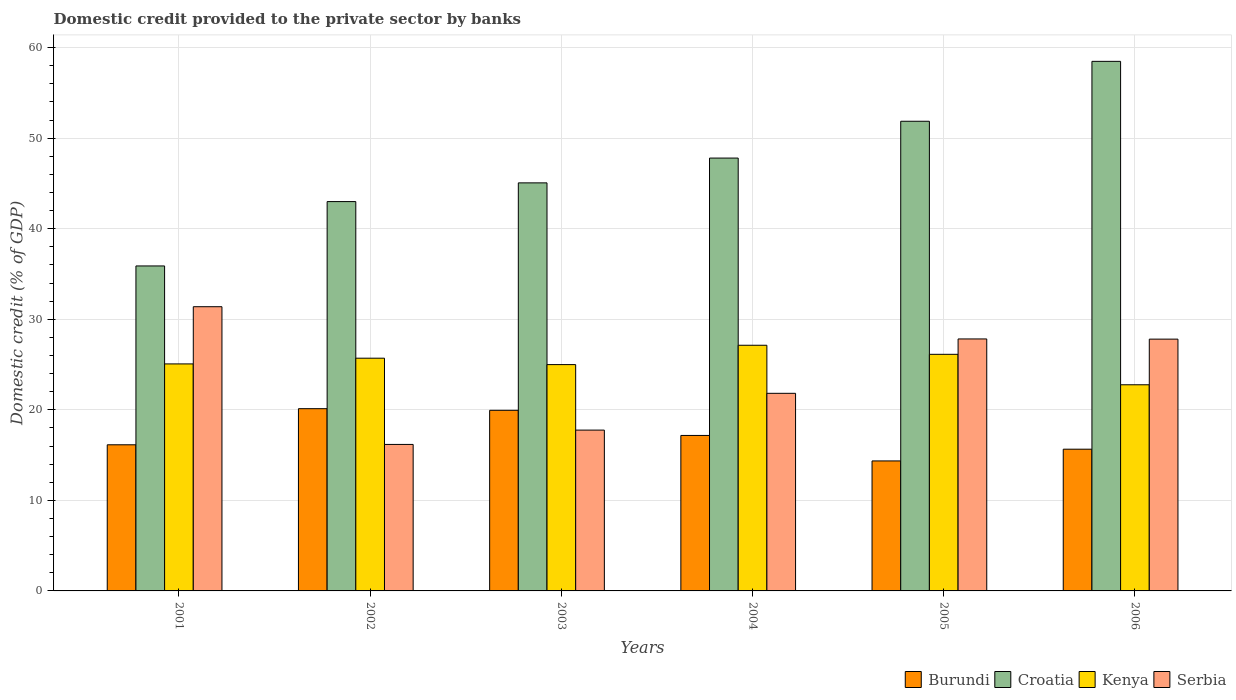How many groups of bars are there?
Make the answer very short. 6. How many bars are there on the 5th tick from the right?
Offer a terse response. 4. What is the label of the 3rd group of bars from the left?
Your response must be concise. 2003. In how many cases, is the number of bars for a given year not equal to the number of legend labels?
Provide a succinct answer. 0. What is the domestic credit provided to the private sector by banks in Serbia in 2003?
Your response must be concise. 17.76. Across all years, what is the maximum domestic credit provided to the private sector by banks in Croatia?
Give a very brief answer. 58.49. Across all years, what is the minimum domestic credit provided to the private sector by banks in Burundi?
Your answer should be compact. 14.36. In which year was the domestic credit provided to the private sector by banks in Burundi maximum?
Your answer should be very brief. 2002. What is the total domestic credit provided to the private sector by banks in Croatia in the graph?
Offer a very short reply. 282.12. What is the difference between the domestic credit provided to the private sector by banks in Serbia in 2001 and that in 2003?
Make the answer very short. 13.63. What is the difference between the domestic credit provided to the private sector by banks in Serbia in 2003 and the domestic credit provided to the private sector by banks in Burundi in 2001?
Provide a short and direct response. 1.62. What is the average domestic credit provided to the private sector by banks in Kenya per year?
Keep it short and to the point. 25.3. In the year 2006, what is the difference between the domestic credit provided to the private sector by banks in Croatia and domestic credit provided to the private sector by banks in Kenya?
Make the answer very short. 35.72. What is the ratio of the domestic credit provided to the private sector by banks in Kenya in 2002 to that in 2004?
Your response must be concise. 0.95. Is the domestic credit provided to the private sector by banks in Croatia in 2004 less than that in 2006?
Your response must be concise. Yes. Is the difference between the domestic credit provided to the private sector by banks in Croatia in 2003 and 2006 greater than the difference between the domestic credit provided to the private sector by banks in Kenya in 2003 and 2006?
Ensure brevity in your answer.  No. What is the difference between the highest and the second highest domestic credit provided to the private sector by banks in Serbia?
Offer a terse response. 3.56. What is the difference between the highest and the lowest domestic credit provided to the private sector by banks in Serbia?
Provide a succinct answer. 15.21. Is it the case that in every year, the sum of the domestic credit provided to the private sector by banks in Burundi and domestic credit provided to the private sector by banks in Kenya is greater than the sum of domestic credit provided to the private sector by banks in Croatia and domestic credit provided to the private sector by banks in Serbia?
Offer a very short reply. No. What does the 2nd bar from the left in 2002 represents?
Ensure brevity in your answer.  Croatia. What does the 2nd bar from the right in 2006 represents?
Your answer should be very brief. Kenya. Are all the bars in the graph horizontal?
Give a very brief answer. No. How many years are there in the graph?
Give a very brief answer. 6. Does the graph contain any zero values?
Make the answer very short. No. Where does the legend appear in the graph?
Provide a short and direct response. Bottom right. How many legend labels are there?
Your response must be concise. 4. How are the legend labels stacked?
Offer a very short reply. Horizontal. What is the title of the graph?
Provide a succinct answer. Domestic credit provided to the private sector by banks. Does "Malaysia" appear as one of the legend labels in the graph?
Your answer should be compact. No. What is the label or title of the X-axis?
Keep it short and to the point. Years. What is the label or title of the Y-axis?
Offer a terse response. Domestic credit (% of GDP). What is the Domestic credit (% of GDP) of Burundi in 2001?
Keep it short and to the point. 16.14. What is the Domestic credit (% of GDP) in Croatia in 2001?
Give a very brief answer. 35.89. What is the Domestic credit (% of GDP) in Kenya in 2001?
Your answer should be compact. 25.07. What is the Domestic credit (% of GDP) in Serbia in 2001?
Provide a succinct answer. 31.39. What is the Domestic credit (% of GDP) in Burundi in 2002?
Offer a very short reply. 20.13. What is the Domestic credit (% of GDP) of Croatia in 2002?
Your answer should be very brief. 43. What is the Domestic credit (% of GDP) of Kenya in 2002?
Make the answer very short. 25.7. What is the Domestic credit (% of GDP) in Serbia in 2002?
Give a very brief answer. 16.18. What is the Domestic credit (% of GDP) in Burundi in 2003?
Your answer should be very brief. 19.95. What is the Domestic credit (% of GDP) of Croatia in 2003?
Give a very brief answer. 45.07. What is the Domestic credit (% of GDP) of Kenya in 2003?
Your answer should be compact. 24.99. What is the Domestic credit (% of GDP) of Serbia in 2003?
Ensure brevity in your answer.  17.76. What is the Domestic credit (% of GDP) of Burundi in 2004?
Provide a short and direct response. 17.17. What is the Domestic credit (% of GDP) of Croatia in 2004?
Provide a short and direct response. 47.8. What is the Domestic credit (% of GDP) in Kenya in 2004?
Your answer should be compact. 27.13. What is the Domestic credit (% of GDP) of Serbia in 2004?
Offer a terse response. 21.82. What is the Domestic credit (% of GDP) of Burundi in 2005?
Offer a very short reply. 14.36. What is the Domestic credit (% of GDP) in Croatia in 2005?
Provide a short and direct response. 51.87. What is the Domestic credit (% of GDP) of Kenya in 2005?
Offer a terse response. 26.13. What is the Domestic credit (% of GDP) of Serbia in 2005?
Offer a very short reply. 27.83. What is the Domestic credit (% of GDP) of Burundi in 2006?
Your answer should be compact. 15.65. What is the Domestic credit (% of GDP) in Croatia in 2006?
Keep it short and to the point. 58.49. What is the Domestic credit (% of GDP) in Kenya in 2006?
Make the answer very short. 22.77. What is the Domestic credit (% of GDP) of Serbia in 2006?
Offer a very short reply. 27.81. Across all years, what is the maximum Domestic credit (% of GDP) in Burundi?
Provide a short and direct response. 20.13. Across all years, what is the maximum Domestic credit (% of GDP) of Croatia?
Your answer should be very brief. 58.49. Across all years, what is the maximum Domestic credit (% of GDP) in Kenya?
Your response must be concise. 27.13. Across all years, what is the maximum Domestic credit (% of GDP) of Serbia?
Offer a very short reply. 31.39. Across all years, what is the minimum Domestic credit (% of GDP) of Burundi?
Ensure brevity in your answer.  14.36. Across all years, what is the minimum Domestic credit (% of GDP) in Croatia?
Your answer should be compact. 35.89. Across all years, what is the minimum Domestic credit (% of GDP) of Kenya?
Provide a short and direct response. 22.77. Across all years, what is the minimum Domestic credit (% of GDP) of Serbia?
Provide a succinct answer. 16.18. What is the total Domestic credit (% of GDP) in Burundi in the graph?
Your response must be concise. 103.39. What is the total Domestic credit (% of GDP) in Croatia in the graph?
Offer a terse response. 282.12. What is the total Domestic credit (% of GDP) of Kenya in the graph?
Give a very brief answer. 151.8. What is the total Domestic credit (% of GDP) in Serbia in the graph?
Offer a terse response. 142.79. What is the difference between the Domestic credit (% of GDP) of Burundi in 2001 and that in 2002?
Your response must be concise. -3.99. What is the difference between the Domestic credit (% of GDP) in Croatia in 2001 and that in 2002?
Provide a succinct answer. -7.11. What is the difference between the Domestic credit (% of GDP) of Kenya in 2001 and that in 2002?
Offer a terse response. -0.63. What is the difference between the Domestic credit (% of GDP) of Serbia in 2001 and that in 2002?
Ensure brevity in your answer.  15.21. What is the difference between the Domestic credit (% of GDP) in Burundi in 2001 and that in 2003?
Make the answer very short. -3.81. What is the difference between the Domestic credit (% of GDP) of Croatia in 2001 and that in 2003?
Keep it short and to the point. -9.18. What is the difference between the Domestic credit (% of GDP) in Kenya in 2001 and that in 2003?
Give a very brief answer. 0.08. What is the difference between the Domestic credit (% of GDP) of Serbia in 2001 and that in 2003?
Make the answer very short. 13.63. What is the difference between the Domestic credit (% of GDP) in Burundi in 2001 and that in 2004?
Make the answer very short. -1.03. What is the difference between the Domestic credit (% of GDP) in Croatia in 2001 and that in 2004?
Give a very brief answer. -11.91. What is the difference between the Domestic credit (% of GDP) in Kenya in 2001 and that in 2004?
Offer a terse response. -2.06. What is the difference between the Domestic credit (% of GDP) in Serbia in 2001 and that in 2004?
Provide a short and direct response. 9.56. What is the difference between the Domestic credit (% of GDP) of Burundi in 2001 and that in 2005?
Make the answer very short. 1.78. What is the difference between the Domestic credit (% of GDP) in Croatia in 2001 and that in 2005?
Offer a very short reply. -15.98. What is the difference between the Domestic credit (% of GDP) of Kenya in 2001 and that in 2005?
Give a very brief answer. -1.06. What is the difference between the Domestic credit (% of GDP) of Serbia in 2001 and that in 2005?
Your answer should be very brief. 3.56. What is the difference between the Domestic credit (% of GDP) in Burundi in 2001 and that in 2006?
Make the answer very short. 0.49. What is the difference between the Domestic credit (% of GDP) of Croatia in 2001 and that in 2006?
Give a very brief answer. -22.6. What is the difference between the Domestic credit (% of GDP) in Kenya in 2001 and that in 2006?
Make the answer very short. 2.3. What is the difference between the Domestic credit (% of GDP) of Serbia in 2001 and that in 2006?
Your response must be concise. 3.58. What is the difference between the Domestic credit (% of GDP) in Burundi in 2002 and that in 2003?
Make the answer very short. 0.18. What is the difference between the Domestic credit (% of GDP) of Croatia in 2002 and that in 2003?
Provide a succinct answer. -2.07. What is the difference between the Domestic credit (% of GDP) of Kenya in 2002 and that in 2003?
Offer a very short reply. 0.71. What is the difference between the Domestic credit (% of GDP) of Serbia in 2002 and that in 2003?
Keep it short and to the point. -1.58. What is the difference between the Domestic credit (% of GDP) in Burundi in 2002 and that in 2004?
Provide a short and direct response. 2.96. What is the difference between the Domestic credit (% of GDP) in Croatia in 2002 and that in 2004?
Keep it short and to the point. -4.81. What is the difference between the Domestic credit (% of GDP) in Kenya in 2002 and that in 2004?
Your answer should be compact. -1.43. What is the difference between the Domestic credit (% of GDP) of Serbia in 2002 and that in 2004?
Keep it short and to the point. -5.64. What is the difference between the Domestic credit (% of GDP) in Burundi in 2002 and that in 2005?
Give a very brief answer. 5.77. What is the difference between the Domestic credit (% of GDP) of Croatia in 2002 and that in 2005?
Ensure brevity in your answer.  -8.87. What is the difference between the Domestic credit (% of GDP) of Kenya in 2002 and that in 2005?
Ensure brevity in your answer.  -0.43. What is the difference between the Domestic credit (% of GDP) in Serbia in 2002 and that in 2005?
Give a very brief answer. -11.65. What is the difference between the Domestic credit (% of GDP) of Burundi in 2002 and that in 2006?
Make the answer very short. 4.47. What is the difference between the Domestic credit (% of GDP) of Croatia in 2002 and that in 2006?
Offer a very short reply. -15.49. What is the difference between the Domestic credit (% of GDP) in Kenya in 2002 and that in 2006?
Provide a succinct answer. 2.93. What is the difference between the Domestic credit (% of GDP) in Serbia in 2002 and that in 2006?
Keep it short and to the point. -11.63. What is the difference between the Domestic credit (% of GDP) in Burundi in 2003 and that in 2004?
Give a very brief answer. 2.78. What is the difference between the Domestic credit (% of GDP) of Croatia in 2003 and that in 2004?
Your response must be concise. -2.74. What is the difference between the Domestic credit (% of GDP) in Kenya in 2003 and that in 2004?
Provide a succinct answer. -2.14. What is the difference between the Domestic credit (% of GDP) in Serbia in 2003 and that in 2004?
Offer a very short reply. -4.06. What is the difference between the Domestic credit (% of GDP) in Burundi in 2003 and that in 2005?
Provide a succinct answer. 5.59. What is the difference between the Domestic credit (% of GDP) in Croatia in 2003 and that in 2005?
Offer a terse response. -6.8. What is the difference between the Domestic credit (% of GDP) in Kenya in 2003 and that in 2005?
Provide a short and direct response. -1.14. What is the difference between the Domestic credit (% of GDP) of Serbia in 2003 and that in 2005?
Offer a very short reply. -10.07. What is the difference between the Domestic credit (% of GDP) in Burundi in 2003 and that in 2006?
Make the answer very short. 4.29. What is the difference between the Domestic credit (% of GDP) in Croatia in 2003 and that in 2006?
Provide a short and direct response. -13.42. What is the difference between the Domestic credit (% of GDP) in Kenya in 2003 and that in 2006?
Offer a terse response. 2.23. What is the difference between the Domestic credit (% of GDP) in Serbia in 2003 and that in 2006?
Your response must be concise. -10.05. What is the difference between the Domestic credit (% of GDP) in Burundi in 2004 and that in 2005?
Your answer should be compact. 2.81. What is the difference between the Domestic credit (% of GDP) in Croatia in 2004 and that in 2005?
Your answer should be very brief. -4.06. What is the difference between the Domestic credit (% of GDP) in Serbia in 2004 and that in 2005?
Make the answer very short. -6. What is the difference between the Domestic credit (% of GDP) of Burundi in 2004 and that in 2006?
Your answer should be very brief. 1.52. What is the difference between the Domestic credit (% of GDP) of Croatia in 2004 and that in 2006?
Make the answer very short. -10.68. What is the difference between the Domestic credit (% of GDP) in Kenya in 2004 and that in 2006?
Your answer should be compact. 4.36. What is the difference between the Domestic credit (% of GDP) in Serbia in 2004 and that in 2006?
Ensure brevity in your answer.  -5.98. What is the difference between the Domestic credit (% of GDP) in Burundi in 2005 and that in 2006?
Your answer should be very brief. -1.3. What is the difference between the Domestic credit (% of GDP) in Croatia in 2005 and that in 2006?
Your answer should be compact. -6.62. What is the difference between the Domestic credit (% of GDP) in Kenya in 2005 and that in 2006?
Make the answer very short. 3.36. What is the difference between the Domestic credit (% of GDP) in Serbia in 2005 and that in 2006?
Keep it short and to the point. 0.02. What is the difference between the Domestic credit (% of GDP) in Burundi in 2001 and the Domestic credit (% of GDP) in Croatia in 2002?
Keep it short and to the point. -26.86. What is the difference between the Domestic credit (% of GDP) of Burundi in 2001 and the Domestic credit (% of GDP) of Kenya in 2002?
Ensure brevity in your answer.  -9.56. What is the difference between the Domestic credit (% of GDP) in Burundi in 2001 and the Domestic credit (% of GDP) in Serbia in 2002?
Offer a very short reply. -0.04. What is the difference between the Domestic credit (% of GDP) of Croatia in 2001 and the Domestic credit (% of GDP) of Kenya in 2002?
Make the answer very short. 10.19. What is the difference between the Domestic credit (% of GDP) in Croatia in 2001 and the Domestic credit (% of GDP) in Serbia in 2002?
Provide a succinct answer. 19.71. What is the difference between the Domestic credit (% of GDP) in Kenya in 2001 and the Domestic credit (% of GDP) in Serbia in 2002?
Make the answer very short. 8.89. What is the difference between the Domestic credit (% of GDP) of Burundi in 2001 and the Domestic credit (% of GDP) of Croatia in 2003?
Make the answer very short. -28.93. What is the difference between the Domestic credit (% of GDP) of Burundi in 2001 and the Domestic credit (% of GDP) of Kenya in 2003?
Provide a succinct answer. -8.86. What is the difference between the Domestic credit (% of GDP) in Burundi in 2001 and the Domestic credit (% of GDP) in Serbia in 2003?
Ensure brevity in your answer.  -1.62. What is the difference between the Domestic credit (% of GDP) in Croatia in 2001 and the Domestic credit (% of GDP) in Kenya in 2003?
Keep it short and to the point. 10.9. What is the difference between the Domestic credit (% of GDP) in Croatia in 2001 and the Domestic credit (% of GDP) in Serbia in 2003?
Make the answer very short. 18.13. What is the difference between the Domestic credit (% of GDP) in Kenya in 2001 and the Domestic credit (% of GDP) in Serbia in 2003?
Make the answer very short. 7.31. What is the difference between the Domestic credit (% of GDP) in Burundi in 2001 and the Domestic credit (% of GDP) in Croatia in 2004?
Your answer should be very brief. -31.67. What is the difference between the Domestic credit (% of GDP) in Burundi in 2001 and the Domestic credit (% of GDP) in Kenya in 2004?
Make the answer very short. -10.99. What is the difference between the Domestic credit (% of GDP) in Burundi in 2001 and the Domestic credit (% of GDP) in Serbia in 2004?
Keep it short and to the point. -5.68. What is the difference between the Domestic credit (% of GDP) in Croatia in 2001 and the Domestic credit (% of GDP) in Kenya in 2004?
Give a very brief answer. 8.76. What is the difference between the Domestic credit (% of GDP) in Croatia in 2001 and the Domestic credit (% of GDP) in Serbia in 2004?
Make the answer very short. 14.07. What is the difference between the Domestic credit (% of GDP) in Kenya in 2001 and the Domestic credit (% of GDP) in Serbia in 2004?
Ensure brevity in your answer.  3.25. What is the difference between the Domestic credit (% of GDP) of Burundi in 2001 and the Domestic credit (% of GDP) of Croatia in 2005?
Offer a very short reply. -35.73. What is the difference between the Domestic credit (% of GDP) in Burundi in 2001 and the Domestic credit (% of GDP) in Kenya in 2005?
Your answer should be compact. -9.99. What is the difference between the Domestic credit (% of GDP) of Burundi in 2001 and the Domestic credit (% of GDP) of Serbia in 2005?
Offer a terse response. -11.69. What is the difference between the Domestic credit (% of GDP) in Croatia in 2001 and the Domestic credit (% of GDP) in Kenya in 2005?
Keep it short and to the point. 9.76. What is the difference between the Domestic credit (% of GDP) in Croatia in 2001 and the Domestic credit (% of GDP) in Serbia in 2005?
Your answer should be compact. 8.06. What is the difference between the Domestic credit (% of GDP) of Kenya in 2001 and the Domestic credit (% of GDP) of Serbia in 2005?
Your response must be concise. -2.76. What is the difference between the Domestic credit (% of GDP) in Burundi in 2001 and the Domestic credit (% of GDP) in Croatia in 2006?
Your response must be concise. -42.35. What is the difference between the Domestic credit (% of GDP) of Burundi in 2001 and the Domestic credit (% of GDP) of Kenya in 2006?
Your response must be concise. -6.63. What is the difference between the Domestic credit (% of GDP) of Burundi in 2001 and the Domestic credit (% of GDP) of Serbia in 2006?
Your response must be concise. -11.67. What is the difference between the Domestic credit (% of GDP) of Croatia in 2001 and the Domestic credit (% of GDP) of Kenya in 2006?
Make the answer very short. 13.12. What is the difference between the Domestic credit (% of GDP) in Croatia in 2001 and the Domestic credit (% of GDP) in Serbia in 2006?
Make the answer very short. 8.08. What is the difference between the Domestic credit (% of GDP) in Kenya in 2001 and the Domestic credit (% of GDP) in Serbia in 2006?
Offer a terse response. -2.74. What is the difference between the Domestic credit (% of GDP) in Burundi in 2002 and the Domestic credit (% of GDP) in Croatia in 2003?
Your answer should be very brief. -24.94. What is the difference between the Domestic credit (% of GDP) of Burundi in 2002 and the Domestic credit (% of GDP) of Kenya in 2003?
Your response must be concise. -4.87. What is the difference between the Domestic credit (% of GDP) in Burundi in 2002 and the Domestic credit (% of GDP) in Serbia in 2003?
Provide a succinct answer. 2.37. What is the difference between the Domestic credit (% of GDP) in Croatia in 2002 and the Domestic credit (% of GDP) in Kenya in 2003?
Your response must be concise. 18. What is the difference between the Domestic credit (% of GDP) of Croatia in 2002 and the Domestic credit (% of GDP) of Serbia in 2003?
Provide a short and direct response. 25.24. What is the difference between the Domestic credit (% of GDP) in Kenya in 2002 and the Domestic credit (% of GDP) in Serbia in 2003?
Your response must be concise. 7.94. What is the difference between the Domestic credit (% of GDP) in Burundi in 2002 and the Domestic credit (% of GDP) in Croatia in 2004?
Provide a succinct answer. -27.68. What is the difference between the Domestic credit (% of GDP) of Burundi in 2002 and the Domestic credit (% of GDP) of Kenya in 2004?
Give a very brief answer. -7.01. What is the difference between the Domestic credit (% of GDP) in Burundi in 2002 and the Domestic credit (% of GDP) in Serbia in 2004?
Ensure brevity in your answer.  -1.7. What is the difference between the Domestic credit (% of GDP) in Croatia in 2002 and the Domestic credit (% of GDP) in Kenya in 2004?
Keep it short and to the point. 15.87. What is the difference between the Domestic credit (% of GDP) of Croatia in 2002 and the Domestic credit (% of GDP) of Serbia in 2004?
Your answer should be compact. 21.18. What is the difference between the Domestic credit (% of GDP) in Kenya in 2002 and the Domestic credit (% of GDP) in Serbia in 2004?
Offer a terse response. 3.88. What is the difference between the Domestic credit (% of GDP) of Burundi in 2002 and the Domestic credit (% of GDP) of Croatia in 2005?
Provide a short and direct response. -31.74. What is the difference between the Domestic credit (% of GDP) of Burundi in 2002 and the Domestic credit (% of GDP) of Kenya in 2005?
Provide a succinct answer. -6.01. What is the difference between the Domestic credit (% of GDP) in Burundi in 2002 and the Domestic credit (% of GDP) in Serbia in 2005?
Offer a very short reply. -7.7. What is the difference between the Domestic credit (% of GDP) in Croatia in 2002 and the Domestic credit (% of GDP) in Kenya in 2005?
Offer a very short reply. 16.87. What is the difference between the Domestic credit (% of GDP) of Croatia in 2002 and the Domestic credit (% of GDP) of Serbia in 2005?
Keep it short and to the point. 15.17. What is the difference between the Domestic credit (% of GDP) of Kenya in 2002 and the Domestic credit (% of GDP) of Serbia in 2005?
Provide a succinct answer. -2.13. What is the difference between the Domestic credit (% of GDP) of Burundi in 2002 and the Domestic credit (% of GDP) of Croatia in 2006?
Offer a terse response. -38.36. What is the difference between the Domestic credit (% of GDP) of Burundi in 2002 and the Domestic credit (% of GDP) of Kenya in 2006?
Your response must be concise. -2.64. What is the difference between the Domestic credit (% of GDP) of Burundi in 2002 and the Domestic credit (% of GDP) of Serbia in 2006?
Keep it short and to the point. -7.68. What is the difference between the Domestic credit (% of GDP) of Croatia in 2002 and the Domestic credit (% of GDP) of Kenya in 2006?
Keep it short and to the point. 20.23. What is the difference between the Domestic credit (% of GDP) of Croatia in 2002 and the Domestic credit (% of GDP) of Serbia in 2006?
Your answer should be compact. 15.19. What is the difference between the Domestic credit (% of GDP) of Kenya in 2002 and the Domestic credit (% of GDP) of Serbia in 2006?
Give a very brief answer. -2.11. What is the difference between the Domestic credit (% of GDP) in Burundi in 2003 and the Domestic credit (% of GDP) in Croatia in 2004?
Keep it short and to the point. -27.86. What is the difference between the Domestic credit (% of GDP) of Burundi in 2003 and the Domestic credit (% of GDP) of Kenya in 2004?
Ensure brevity in your answer.  -7.18. What is the difference between the Domestic credit (% of GDP) of Burundi in 2003 and the Domestic credit (% of GDP) of Serbia in 2004?
Provide a succinct answer. -1.88. What is the difference between the Domestic credit (% of GDP) in Croatia in 2003 and the Domestic credit (% of GDP) in Kenya in 2004?
Your answer should be compact. 17.93. What is the difference between the Domestic credit (% of GDP) of Croatia in 2003 and the Domestic credit (% of GDP) of Serbia in 2004?
Provide a short and direct response. 23.24. What is the difference between the Domestic credit (% of GDP) of Kenya in 2003 and the Domestic credit (% of GDP) of Serbia in 2004?
Offer a terse response. 3.17. What is the difference between the Domestic credit (% of GDP) in Burundi in 2003 and the Domestic credit (% of GDP) in Croatia in 2005?
Your response must be concise. -31.92. What is the difference between the Domestic credit (% of GDP) in Burundi in 2003 and the Domestic credit (% of GDP) in Kenya in 2005?
Give a very brief answer. -6.18. What is the difference between the Domestic credit (% of GDP) in Burundi in 2003 and the Domestic credit (% of GDP) in Serbia in 2005?
Offer a terse response. -7.88. What is the difference between the Domestic credit (% of GDP) in Croatia in 2003 and the Domestic credit (% of GDP) in Kenya in 2005?
Your response must be concise. 18.93. What is the difference between the Domestic credit (% of GDP) in Croatia in 2003 and the Domestic credit (% of GDP) in Serbia in 2005?
Provide a succinct answer. 17.24. What is the difference between the Domestic credit (% of GDP) in Kenya in 2003 and the Domestic credit (% of GDP) in Serbia in 2005?
Give a very brief answer. -2.83. What is the difference between the Domestic credit (% of GDP) of Burundi in 2003 and the Domestic credit (% of GDP) of Croatia in 2006?
Provide a succinct answer. -38.54. What is the difference between the Domestic credit (% of GDP) of Burundi in 2003 and the Domestic credit (% of GDP) of Kenya in 2006?
Offer a terse response. -2.82. What is the difference between the Domestic credit (% of GDP) of Burundi in 2003 and the Domestic credit (% of GDP) of Serbia in 2006?
Make the answer very short. -7.86. What is the difference between the Domestic credit (% of GDP) of Croatia in 2003 and the Domestic credit (% of GDP) of Kenya in 2006?
Make the answer very short. 22.3. What is the difference between the Domestic credit (% of GDP) in Croatia in 2003 and the Domestic credit (% of GDP) in Serbia in 2006?
Give a very brief answer. 17.26. What is the difference between the Domestic credit (% of GDP) of Kenya in 2003 and the Domestic credit (% of GDP) of Serbia in 2006?
Make the answer very short. -2.81. What is the difference between the Domestic credit (% of GDP) in Burundi in 2004 and the Domestic credit (% of GDP) in Croatia in 2005?
Provide a succinct answer. -34.7. What is the difference between the Domestic credit (% of GDP) in Burundi in 2004 and the Domestic credit (% of GDP) in Kenya in 2005?
Keep it short and to the point. -8.96. What is the difference between the Domestic credit (% of GDP) in Burundi in 2004 and the Domestic credit (% of GDP) in Serbia in 2005?
Your answer should be compact. -10.66. What is the difference between the Domestic credit (% of GDP) of Croatia in 2004 and the Domestic credit (% of GDP) of Kenya in 2005?
Keep it short and to the point. 21.67. What is the difference between the Domestic credit (% of GDP) in Croatia in 2004 and the Domestic credit (% of GDP) in Serbia in 2005?
Your answer should be very brief. 19.98. What is the difference between the Domestic credit (% of GDP) in Kenya in 2004 and the Domestic credit (% of GDP) in Serbia in 2005?
Your response must be concise. -0.7. What is the difference between the Domestic credit (% of GDP) in Burundi in 2004 and the Domestic credit (% of GDP) in Croatia in 2006?
Keep it short and to the point. -41.32. What is the difference between the Domestic credit (% of GDP) in Burundi in 2004 and the Domestic credit (% of GDP) in Kenya in 2006?
Provide a short and direct response. -5.6. What is the difference between the Domestic credit (% of GDP) in Burundi in 2004 and the Domestic credit (% of GDP) in Serbia in 2006?
Your answer should be very brief. -10.64. What is the difference between the Domestic credit (% of GDP) in Croatia in 2004 and the Domestic credit (% of GDP) in Kenya in 2006?
Your response must be concise. 25.04. What is the difference between the Domestic credit (% of GDP) in Croatia in 2004 and the Domestic credit (% of GDP) in Serbia in 2006?
Keep it short and to the point. 20. What is the difference between the Domestic credit (% of GDP) of Kenya in 2004 and the Domestic credit (% of GDP) of Serbia in 2006?
Make the answer very short. -0.68. What is the difference between the Domestic credit (% of GDP) of Burundi in 2005 and the Domestic credit (% of GDP) of Croatia in 2006?
Provide a succinct answer. -44.13. What is the difference between the Domestic credit (% of GDP) in Burundi in 2005 and the Domestic credit (% of GDP) in Kenya in 2006?
Give a very brief answer. -8.41. What is the difference between the Domestic credit (% of GDP) of Burundi in 2005 and the Domestic credit (% of GDP) of Serbia in 2006?
Give a very brief answer. -13.45. What is the difference between the Domestic credit (% of GDP) of Croatia in 2005 and the Domestic credit (% of GDP) of Kenya in 2006?
Give a very brief answer. 29.1. What is the difference between the Domestic credit (% of GDP) of Croatia in 2005 and the Domestic credit (% of GDP) of Serbia in 2006?
Provide a short and direct response. 24.06. What is the difference between the Domestic credit (% of GDP) of Kenya in 2005 and the Domestic credit (% of GDP) of Serbia in 2006?
Your answer should be compact. -1.68. What is the average Domestic credit (% of GDP) in Burundi per year?
Offer a very short reply. 17.23. What is the average Domestic credit (% of GDP) of Croatia per year?
Give a very brief answer. 47.02. What is the average Domestic credit (% of GDP) in Kenya per year?
Offer a terse response. 25.3. What is the average Domestic credit (% of GDP) in Serbia per year?
Your response must be concise. 23.8. In the year 2001, what is the difference between the Domestic credit (% of GDP) of Burundi and Domestic credit (% of GDP) of Croatia?
Keep it short and to the point. -19.75. In the year 2001, what is the difference between the Domestic credit (% of GDP) of Burundi and Domestic credit (% of GDP) of Kenya?
Offer a very short reply. -8.93. In the year 2001, what is the difference between the Domestic credit (% of GDP) in Burundi and Domestic credit (% of GDP) in Serbia?
Your answer should be very brief. -15.25. In the year 2001, what is the difference between the Domestic credit (% of GDP) in Croatia and Domestic credit (% of GDP) in Kenya?
Offer a terse response. 10.82. In the year 2001, what is the difference between the Domestic credit (% of GDP) in Croatia and Domestic credit (% of GDP) in Serbia?
Offer a very short reply. 4.5. In the year 2001, what is the difference between the Domestic credit (% of GDP) in Kenya and Domestic credit (% of GDP) in Serbia?
Ensure brevity in your answer.  -6.32. In the year 2002, what is the difference between the Domestic credit (% of GDP) in Burundi and Domestic credit (% of GDP) in Croatia?
Your response must be concise. -22.87. In the year 2002, what is the difference between the Domestic credit (% of GDP) in Burundi and Domestic credit (% of GDP) in Kenya?
Provide a short and direct response. -5.58. In the year 2002, what is the difference between the Domestic credit (% of GDP) of Burundi and Domestic credit (% of GDP) of Serbia?
Your response must be concise. 3.95. In the year 2002, what is the difference between the Domestic credit (% of GDP) in Croatia and Domestic credit (% of GDP) in Kenya?
Your response must be concise. 17.3. In the year 2002, what is the difference between the Domestic credit (% of GDP) in Croatia and Domestic credit (% of GDP) in Serbia?
Ensure brevity in your answer.  26.82. In the year 2002, what is the difference between the Domestic credit (% of GDP) of Kenya and Domestic credit (% of GDP) of Serbia?
Offer a terse response. 9.52. In the year 2003, what is the difference between the Domestic credit (% of GDP) in Burundi and Domestic credit (% of GDP) in Croatia?
Make the answer very short. -25.12. In the year 2003, what is the difference between the Domestic credit (% of GDP) of Burundi and Domestic credit (% of GDP) of Kenya?
Provide a succinct answer. -5.05. In the year 2003, what is the difference between the Domestic credit (% of GDP) of Burundi and Domestic credit (% of GDP) of Serbia?
Keep it short and to the point. 2.19. In the year 2003, what is the difference between the Domestic credit (% of GDP) in Croatia and Domestic credit (% of GDP) in Kenya?
Make the answer very short. 20.07. In the year 2003, what is the difference between the Domestic credit (% of GDP) in Croatia and Domestic credit (% of GDP) in Serbia?
Provide a succinct answer. 27.31. In the year 2003, what is the difference between the Domestic credit (% of GDP) in Kenya and Domestic credit (% of GDP) in Serbia?
Ensure brevity in your answer.  7.23. In the year 2004, what is the difference between the Domestic credit (% of GDP) of Burundi and Domestic credit (% of GDP) of Croatia?
Ensure brevity in your answer.  -30.63. In the year 2004, what is the difference between the Domestic credit (% of GDP) of Burundi and Domestic credit (% of GDP) of Kenya?
Ensure brevity in your answer.  -9.96. In the year 2004, what is the difference between the Domestic credit (% of GDP) of Burundi and Domestic credit (% of GDP) of Serbia?
Offer a very short reply. -4.65. In the year 2004, what is the difference between the Domestic credit (% of GDP) of Croatia and Domestic credit (% of GDP) of Kenya?
Offer a terse response. 20.67. In the year 2004, what is the difference between the Domestic credit (% of GDP) in Croatia and Domestic credit (% of GDP) in Serbia?
Offer a very short reply. 25.98. In the year 2004, what is the difference between the Domestic credit (% of GDP) in Kenya and Domestic credit (% of GDP) in Serbia?
Your answer should be compact. 5.31. In the year 2005, what is the difference between the Domestic credit (% of GDP) in Burundi and Domestic credit (% of GDP) in Croatia?
Your answer should be compact. -37.51. In the year 2005, what is the difference between the Domestic credit (% of GDP) of Burundi and Domestic credit (% of GDP) of Kenya?
Your answer should be very brief. -11.77. In the year 2005, what is the difference between the Domestic credit (% of GDP) in Burundi and Domestic credit (% of GDP) in Serbia?
Make the answer very short. -13.47. In the year 2005, what is the difference between the Domestic credit (% of GDP) in Croatia and Domestic credit (% of GDP) in Kenya?
Your response must be concise. 25.74. In the year 2005, what is the difference between the Domestic credit (% of GDP) in Croatia and Domestic credit (% of GDP) in Serbia?
Your response must be concise. 24.04. In the year 2005, what is the difference between the Domestic credit (% of GDP) in Kenya and Domestic credit (% of GDP) in Serbia?
Ensure brevity in your answer.  -1.7. In the year 2006, what is the difference between the Domestic credit (% of GDP) of Burundi and Domestic credit (% of GDP) of Croatia?
Offer a terse response. -42.83. In the year 2006, what is the difference between the Domestic credit (% of GDP) in Burundi and Domestic credit (% of GDP) in Kenya?
Your answer should be very brief. -7.11. In the year 2006, what is the difference between the Domestic credit (% of GDP) in Burundi and Domestic credit (% of GDP) in Serbia?
Give a very brief answer. -12.16. In the year 2006, what is the difference between the Domestic credit (% of GDP) of Croatia and Domestic credit (% of GDP) of Kenya?
Ensure brevity in your answer.  35.72. In the year 2006, what is the difference between the Domestic credit (% of GDP) in Croatia and Domestic credit (% of GDP) in Serbia?
Provide a succinct answer. 30.68. In the year 2006, what is the difference between the Domestic credit (% of GDP) in Kenya and Domestic credit (% of GDP) in Serbia?
Provide a succinct answer. -5.04. What is the ratio of the Domestic credit (% of GDP) of Burundi in 2001 to that in 2002?
Your answer should be very brief. 0.8. What is the ratio of the Domestic credit (% of GDP) in Croatia in 2001 to that in 2002?
Make the answer very short. 0.83. What is the ratio of the Domestic credit (% of GDP) of Kenya in 2001 to that in 2002?
Offer a very short reply. 0.98. What is the ratio of the Domestic credit (% of GDP) of Serbia in 2001 to that in 2002?
Ensure brevity in your answer.  1.94. What is the ratio of the Domestic credit (% of GDP) of Burundi in 2001 to that in 2003?
Provide a short and direct response. 0.81. What is the ratio of the Domestic credit (% of GDP) of Croatia in 2001 to that in 2003?
Provide a succinct answer. 0.8. What is the ratio of the Domestic credit (% of GDP) of Serbia in 2001 to that in 2003?
Your answer should be very brief. 1.77. What is the ratio of the Domestic credit (% of GDP) in Burundi in 2001 to that in 2004?
Your answer should be very brief. 0.94. What is the ratio of the Domestic credit (% of GDP) in Croatia in 2001 to that in 2004?
Provide a succinct answer. 0.75. What is the ratio of the Domestic credit (% of GDP) of Kenya in 2001 to that in 2004?
Your answer should be compact. 0.92. What is the ratio of the Domestic credit (% of GDP) in Serbia in 2001 to that in 2004?
Provide a succinct answer. 1.44. What is the ratio of the Domestic credit (% of GDP) of Burundi in 2001 to that in 2005?
Keep it short and to the point. 1.12. What is the ratio of the Domestic credit (% of GDP) in Croatia in 2001 to that in 2005?
Make the answer very short. 0.69. What is the ratio of the Domestic credit (% of GDP) in Kenya in 2001 to that in 2005?
Ensure brevity in your answer.  0.96. What is the ratio of the Domestic credit (% of GDP) of Serbia in 2001 to that in 2005?
Your response must be concise. 1.13. What is the ratio of the Domestic credit (% of GDP) in Burundi in 2001 to that in 2006?
Ensure brevity in your answer.  1.03. What is the ratio of the Domestic credit (% of GDP) in Croatia in 2001 to that in 2006?
Make the answer very short. 0.61. What is the ratio of the Domestic credit (% of GDP) of Kenya in 2001 to that in 2006?
Offer a very short reply. 1.1. What is the ratio of the Domestic credit (% of GDP) of Serbia in 2001 to that in 2006?
Provide a short and direct response. 1.13. What is the ratio of the Domestic credit (% of GDP) in Croatia in 2002 to that in 2003?
Provide a short and direct response. 0.95. What is the ratio of the Domestic credit (% of GDP) in Kenya in 2002 to that in 2003?
Your response must be concise. 1.03. What is the ratio of the Domestic credit (% of GDP) in Serbia in 2002 to that in 2003?
Your response must be concise. 0.91. What is the ratio of the Domestic credit (% of GDP) of Burundi in 2002 to that in 2004?
Keep it short and to the point. 1.17. What is the ratio of the Domestic credit (% of GDP) of Croatia in 2002 to that in 2004?
Your answer should be compact. 0.9. What is the ratio of the Domestic credit (% of GDP) of Kenya in 2002 to that in 2004?
Give a very brief answer. 0.95. What is the ratio of the Domestic credit (% of GDP) of Serbia in 2002 to that in 2004?
Provide a succinct answer. 0.74. What is the ratio of the Domestic credit (% of GDP) in Burundi in 2002 to that in 2005?
Give a very brief answer. 1.4. What is the ratio of the Domestic credit (% of GDP) in Croatia in 2002 to that in 2005?
Provide a succinct answer. 0.83. What is the ratio of the Domestic credit (% of GDP) in Kenya in 2002 to that in 2005?
Give a very brief answer. 0.98. What is the ratio of the Domestic credit (% of GDP) of Serbia in 2002 to that in 2005?
Give a very brief answer. 0.58. What is the ratio of the Domestic credit (% of GDP) in Burundi in 2002 to that in 2006?
Offer a terse response. 1.29. What is the ratio of the Domestic credit (% of GDP) of Croatia in 2002 to that in 2006?
Give a very brief answer. 0.74. What is the ratio of the Domestic credit (% of GDP) in Kenya in 2002 to that in 2006?
Ensure brevity in your answer.  1.13. What is the ratio of the Domestic credit (% of GDP) in Serbia in 2002 to that in 2006?
Provide a short and direct response. 0.58. What is the ratio of the Domestic credit (% of GDP) in Burundi in 2003 to that in 2004?
Offer a terse response. 1.16. What is the ratio of the Domestic credit (% of GDP) of Croatia in 2003 to that in 2004?
Give a very brief answer. 0.94. What is the ratio of the Domestic credit (% of GDP) in Kenya in 2003 to that in 2004?
Keep it short and to the point. 0.92. What is the ratio of the Domestic credit (% of GDP) in Serbia in 2003 to that in 2004?
Provide a short and direct response. 0.81. What is the ratio of the Domestic credit (% of GDP) in Burundi in 2003 to that in 2005?
Make the answer very short. 1.39. What is the ratio of the Domestic credit (% of GDP) in Croatia in 2003 to that in 2005?
Give a very brief answer. 0.87. What is the ratio of the Domestic credit (% of GDP) of Kenya in 2003 to that in 2005?
Make the answer very short. 0.96. What is the ratio of the Domestic credit (% of GDP) of Serbia in 2003 to that in 2005?
Make the answer very short. 0.64. What is the ratio of the Domestic credit (% of GDP) of Burundi in 2003 to that in 2006?
Keep it short and to the point. 1.27. What is the ratio of the Domestic credit (% of GDP) of Croatia in 2003 to that in 2006?
Keep it short and to the point. 0.77. What is the ratio of the Domestic credit (% of GDP) in Kenya in 2003 to that in 2006?
Your answer should be compact. 1.1. What is the ratio of the Domestic credit (% of GDP) of Serbia in 2003 to that in 2006?
Your answer should be very brief. 0.64. What is the ratio of the Domestic credit (% of GDP) of Burundi in 2004 to that in 2005?
Provide a succinct answer. 1.2. What is the ratio of the Domestic credit (% of GDP) of Croatia in 2004 to that in 2005?
Offer a very short reply. 0.92. What is the ratio of the Domestic credit (% of GDP) of Kenya in 2004 to that in 2005?
Provide a short and direct response. 1.04. What is the ratio of the Domestic credit (% of GDP) in Serbia in 2004 to that in 2005?
Your answer should be very brief. 0.78. What is the ratio of the Domestic credit (% of GDP) in Burundi in 2004 to that in 2006?
Keep it short and to the point. 1.1. What is the ratio of the Domestic credit (% of GDP) in Croatia in 2004 to that in 2006?
Offer a very short reply. 0.82. What is the ratio of the Domestic credit (% of GDP) of Kenya in 2004 to that in 2006?
Your answer should be very brief. 1.19. What is the ratio of the Domestic credit (% of GDP) of Serbia in 2004 to that in 2006?
Provide a succinct answer. 0.78. What is the ratio of the Domestic credit (% of GDP) of Burundi in 2005 to that in 2006?
Make the answer very short. 0.92. What is the ratio of the Domestic credit (% of GDP) of Croatia in 2005 to that in 2006?
Your answer should be compact. 0.89. What is the ratio of the Domestic credit (% of GDP) of Kenya in 2005 to that in 2006?
Make the answer very short. 1.15. What is the difference between the highest and the second highest Domestic credit (% of GDP) of Burundi?
Provide a short and direct response. 0.18. What is the difference between the highest and the second highest Domestic credit (% of GDP) in Croatia?
Provide a succinct answer. 6.62. What is the difference between the highest and the second highest Domestic credit (% of GDP) of Kenya?
Offer a very short reply. 1. What is the difference between the highest and the second highest Domestic credit (% of GDP) in Serbia?
Make the answer very short. 3.56. What is the difference between the highest and the lowest Domestic credit (% of GDP) in Burundi?
Ensure brevity in your answer.  5.77. What is the difference between the highest and the lowest Domestic credit (% of GDP) in Croatia?
Your answer should be compact. 22.6. What is the difference between the highest and the lowest Domestic credit (% of GDP) of Kenya?
Keep it short and to the point. 4.36. What is the difference between the highest and the lowest Domestic credit (% of GDP) in Serbia?
Make the answer very short. 15.21. 